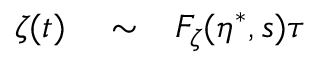Convert formula to latex. <formula><loc_0><loc_0><loc_500><loc_500>\begin{array} { r l r } { \zeta ( t ) } & \sim } & { F _ { \zeta } ( \eta ^ { \ast } , s ) \tau } \end{array}</formula> 